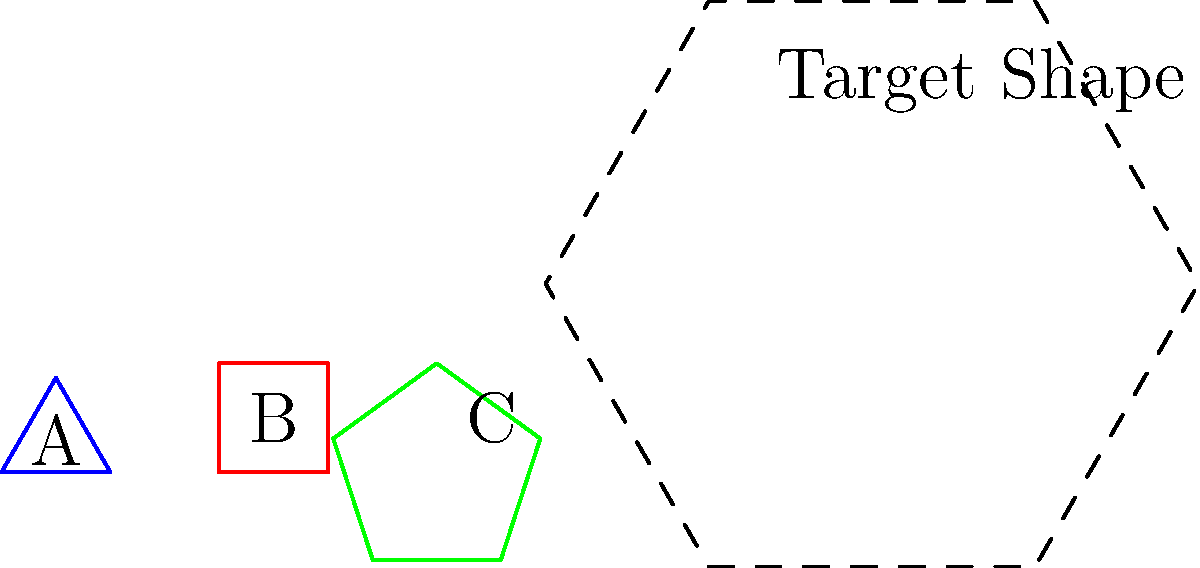As a multinational corporation developing an innovative app for spatial reasoning, you need to create a module that challenges users to mentally assemble geometric shapes. Given the three basic shapes (A, B, and C) and the target outline, which combination of these shapes, when properly arranged and scaled, would form the target shape? Express your answer as an ordered list of shape labels. To solve this problem, we need to analyze the target shape and the given basic shapes:

1. The target shape is a hexagon with alternating long and short sides.

2. Shape A is an equilateral triangle, which can form the top and bottom points of the hexagon.

3. Shape B is a square, which can be rotated to form the left and right points of the hexagon.

4. Shape C is a regular pentagon, which is not needed to form the target shape.

5. To construct the target shape:
   a. Place two triangles (A) at the top and bottom of the hexagon.
   b. Rotate and place two squares (B) on the left and right sides of the hexagon.

6. The arrangement would be:
   - Triangle (A) at the top
   - Square (B) on the right
   - Triangle (A) at the bottom
   - Square (B) on the left

Therefore, the correct combination and order of shapes to form the target hexagon is: A, B, A, B.
Answer: A, B, A, B 